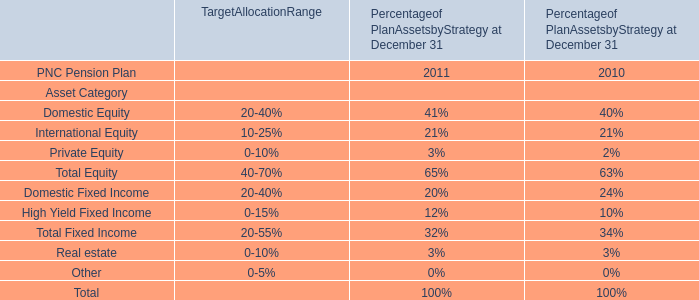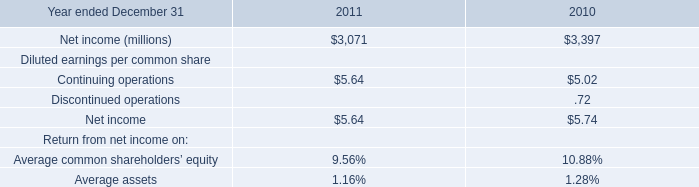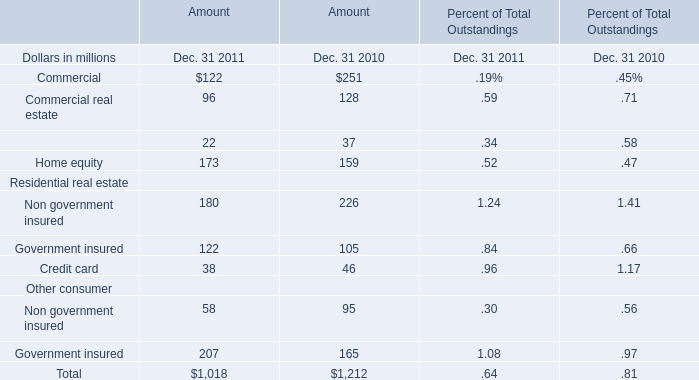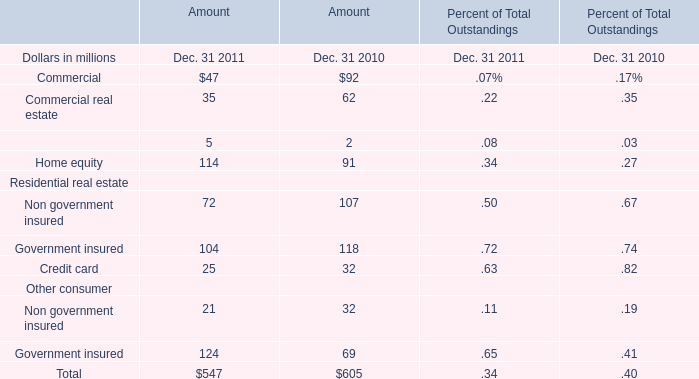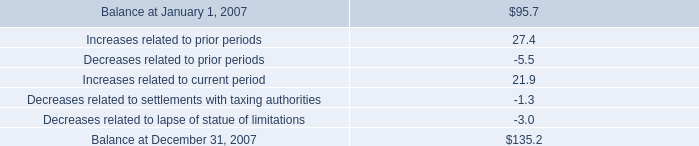What will home equity be like in 2012 if it develops with the same increasing rate as current? (in million) 
Computations: ((((114 - 91) / 91) + 1) * 114)
Answer: 142.81319. 